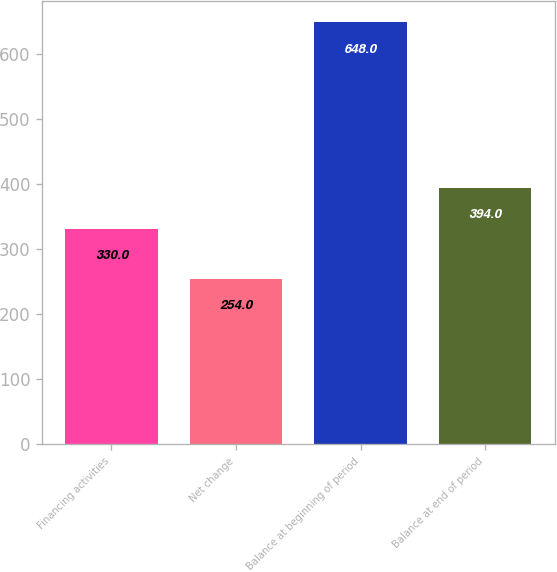<chart> <loc_0><loc_0><loc_500><loc_500><bar_chart><fcel>Financing activities<fcel>Net change<fcel>Balance at beginning of period<fcel>Balance at end of period<nl><fcel>330<fcel>254<fcel>648<fcel>394<nl></chart> 